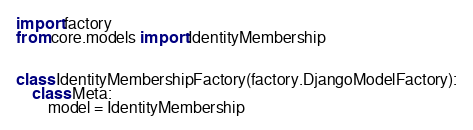<code> <loc_0><loc_0><loc_500><loc_500><_Python_>import factory
from core.models import IdentityMembership


class IdentityMembershipFactory(factory.DjangoModelFactory):
    class Meta:
        model = IdentityMembership
</code> 